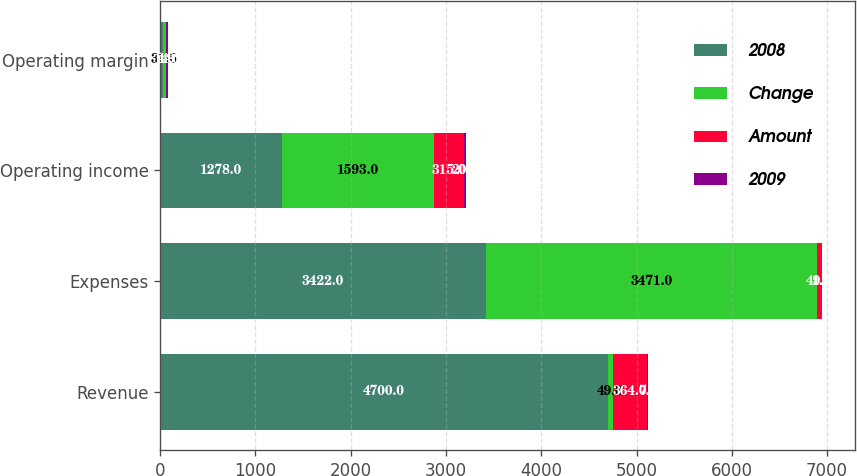<chart> <loc_0><loc_0><loc_500><loc_500><stacked_bar_chart><ecel><fcel>Revenue<fcel>Expenses<fcel>Operating income<fcel>Operating margin<nl><fcel>2008<fcel>4700<fcel>3422<fcel>1278<fcel>27.2<nl><fcel>Change<fcel>49<fcel>3471<fcel>1593<fcel>31.5<nl><fcel>Amount<fcel>364<fcel>49<fcel>315<fcel>4.3<nl><fcel>2009<fcel>7<fcel>1<fcel>20<fcel>14<nl></chart> 